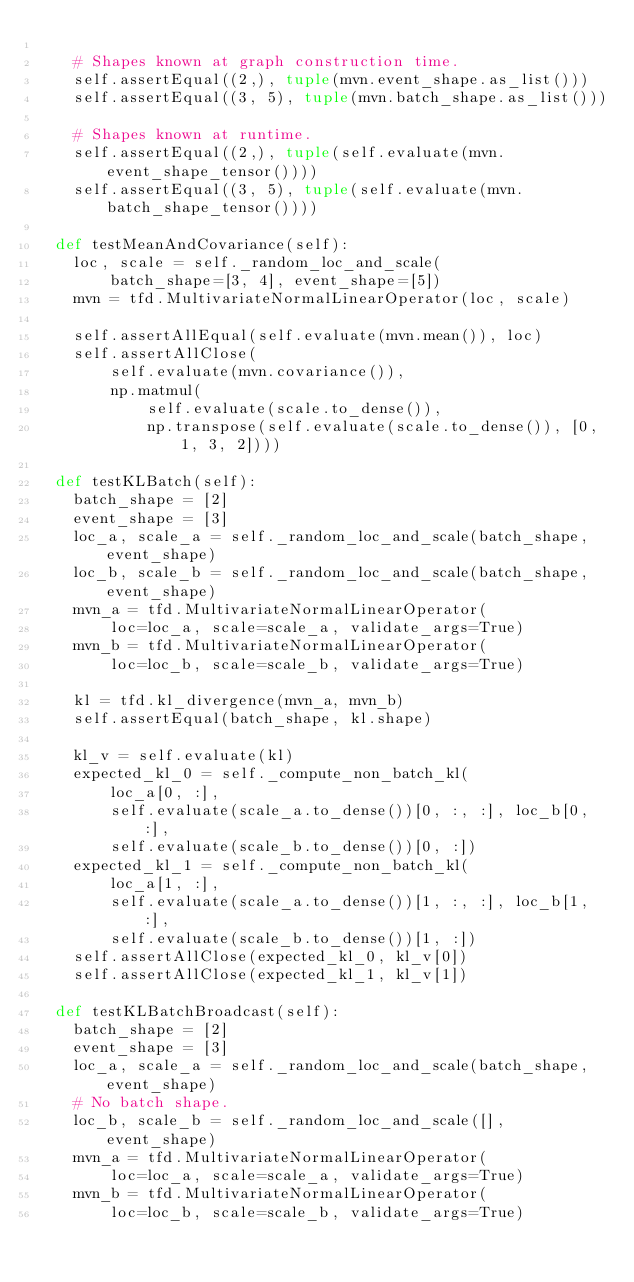Convert code to text. <code><loc_0><loc_0><loc_500><loc_500><_Python_>
    # Shapes known at graph construction time.
    self.assertEqual((2,), tuple(mvn.event_shape.as_list()))
    self.assertEqual((3, 5), tuple(mvn.batch_shape.as_list()))

    # Shapes known at runtime.
    self.assertEqual((2,), tuple(self.evaluate(mvn.event_shape_tensor())))
    self.assertEqual((3, 5), tuple(self.evaluate(mvn.batch_shape_tensor())))

  def testMeanAndCovariance(self):
    loc, scale = self._random_loc_and_scale(
        batch_shape=[3, 4], event_shape=[5])
    mvn = tfd.MultivariateNormalLinearOperator(loc, scale)

    self.assertAllEqual(self.evaluate(mvn.mean()), loc)
    self.assertAllClose(
        self.evaluate(mvn.covariance()),
        np.matmul(
            self.evaluate(scale.to_dense()),
            np.transpose(self.evaluate(scale.to_dense()), [0, 1, 3, 2])))

  def testKLBatch(self):
    batch_shape = [2]
    event_shape = [3]
    loc_a, scale_a = self._random_loc_and_scale(batch_shape, event_shape)
    loc_b, scale_b = self._random_loc_and_scale(batch_shape, event_shape)
    mvn_a = tfd.MultivariateNormalLinearOperator(
        loc=loc_a, scale=scale_a, validate_args=True)
    mvn_b = tfd.MultivariateNormalLinearOperator(
        loc=loc_b, scale=scale_b, validate_args=True)

    kl = tfd.kl_divergence(mvn_a, mvn_b)
    self.assertEqual(batch_shape, kl.shape)

    kl_v = self.evaluate(kl)
    expected_kl_0 = self._compute_non_batch_kl(
        loc_a[0, :],
        self.evaluate(scale_a.to_dense())[0, :, :], loc_b[0, :],
        self.evaluate(scale_b.to_dense())[0, :])
    expected_kl_1 = self._compute_non_batch_kl(
        loc_a[1, :],
        self.evaluate(scale_a.to_dense())[1, :, :], loc_b[1, :],
        self.evaluate(scale_b.to_dense())[1, :])
    self.assertAllClose(expected_kl_0, kl_v[0])
    self.assertAllClose(expected_kl_1, kl_v[1])

  def testKLBatchBroadcast(self):
    batch_shape = [2]
    event_shape = [3]
    loc_a, scale_a = self._random_loc_and_scale(batch_shape, event_shape)
    # No batch shape.
    loc_b, scale_b = self._random_loc_and_scale([], event_shape)
    mvn_a = tfd.MultivariateNormalLinearOperator(
        loc=loc_a, scale=scale_a, validate_args=True)
    mvn_b = tfd.MultivariateNormalLinearOperator(
        loc=loc_b, scale=scale_b, validate_args=True)
</code> 